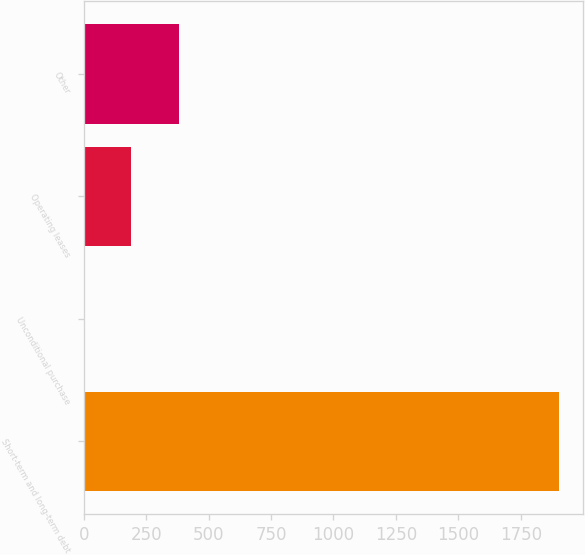Convert chart to OTSL. <chart><loc_0><loc_0><loc_500><loc_500><bar_chart><fcel>Short-term and long-term debt<fcel>Unconditional purchase<fcel>Operating leases<fcel>Other<nl><fcel>1902<fcel>1<fcel>191.1<fcel>381.2<nl></chart> 